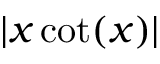<formula> <loc_0><loc_0><loc_500><loc_500>| x \cot ( x ) |</formula> 